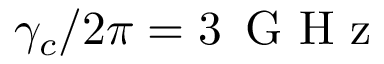<formula> <loc_0><loc_0><loc_500><loc_500>\gamma _ { c } / 2 \pi = 3 \, G H z</formula> 